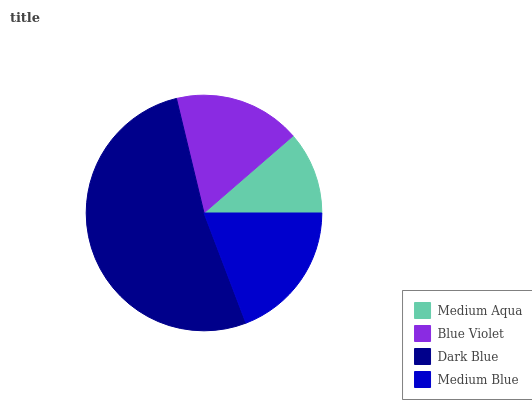Is Medium Aqua the minimum?
Answer yes or no. Yes. Is Dark Blue the maximum?
Answer yes or no. Yes. Is Blue Violet the minimum?
Answer yes or no. No. Is Blue Violet the maximum?
Answer yes or no. No. Is Blue Violet greater than Medium Aqua?
Answer yes or no. Yes. Is Medium Aqua less than Blue Violet?
Answer yes or no. Yes. Is Medium Aqua greater than Blue Violet?
Answer yes or no. No. Is Blue Violet less than Medium Aqua?
Answer yes or no. No. Is Medium Blue the high median?
Answer yes or no. Yes. Is Blue Violet the low median?
Answer yes or no. Yes. Is Medium Aqua the high median?
Answer yes or no. No. Is Medium Aqua the low median?
Answer yes or no. No. 